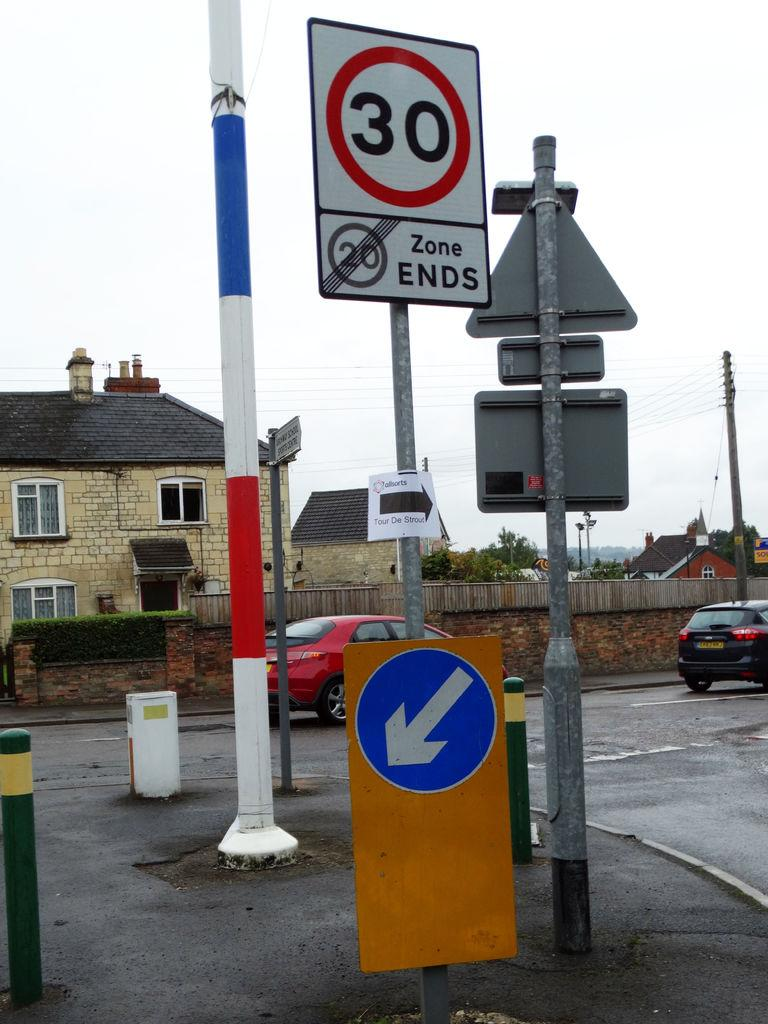<image>
Describe the image concisely. A sign says that the 20 zone ends and the limit is now 30. 